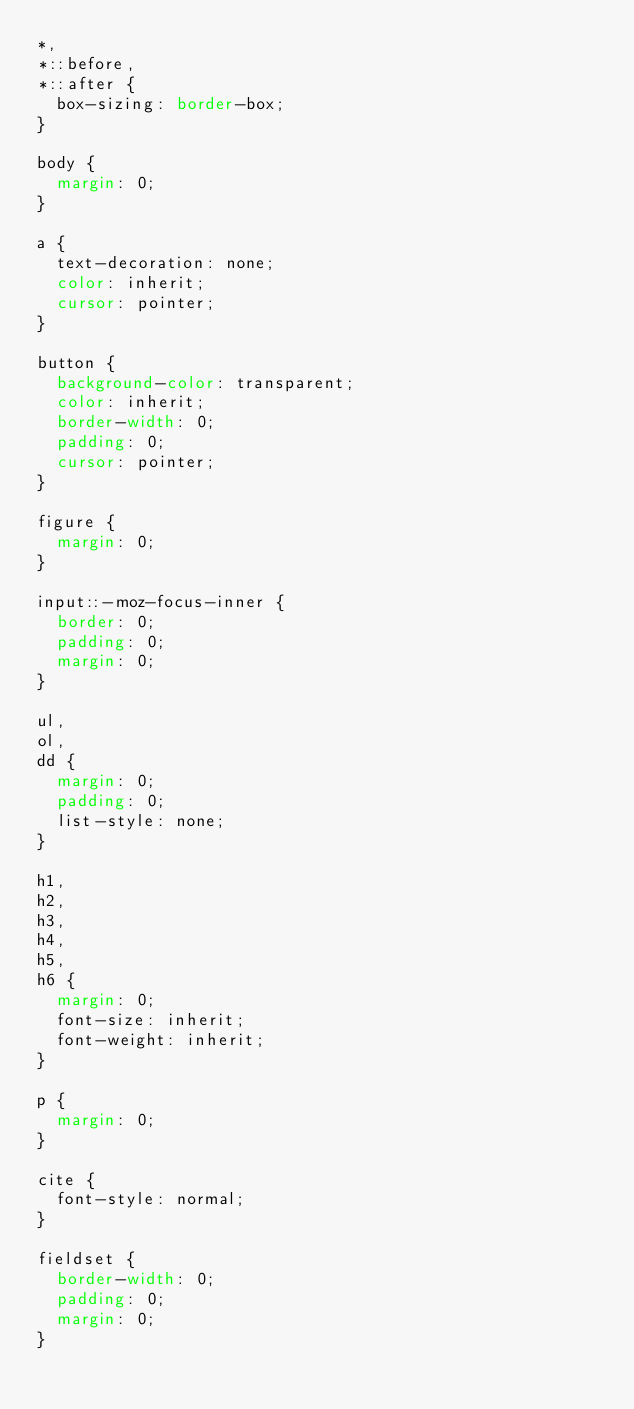Convert code to text. <code><loc_0><loc_0><loc_500><loc_500><_CSS_>*,
*::before,
*::after {
  box-sizing: border-box;
}

body {
  margin: 0;
}

a {
  text-decoration: none;
  color: inherit;
  cursor: pointer;
}

button {
  background-color: transparent;
  color: inherit;
  border-width: 0;
  padding: 0;
  cursor: pointer;
}

figure {
  margin: 0;
}

input::-moz-focus-inner {
  border: 0;
  padding: 0;
  margin: 0;
}

ul,
ol,
dd {
  margin: 0;
  padding: 0;
  list-style: none;
}

h1,
h2,
h3,
h4,
h5,
h6 {
  margin: 0;
  font-size: inherit;
  font-weight: inherit;
}

p {
  margin: 0;
}

cite {
  font-style: normal;
}

fieldset {
  border-width: 0;
  padding: 0;
  margin: 0;
}
</code> 